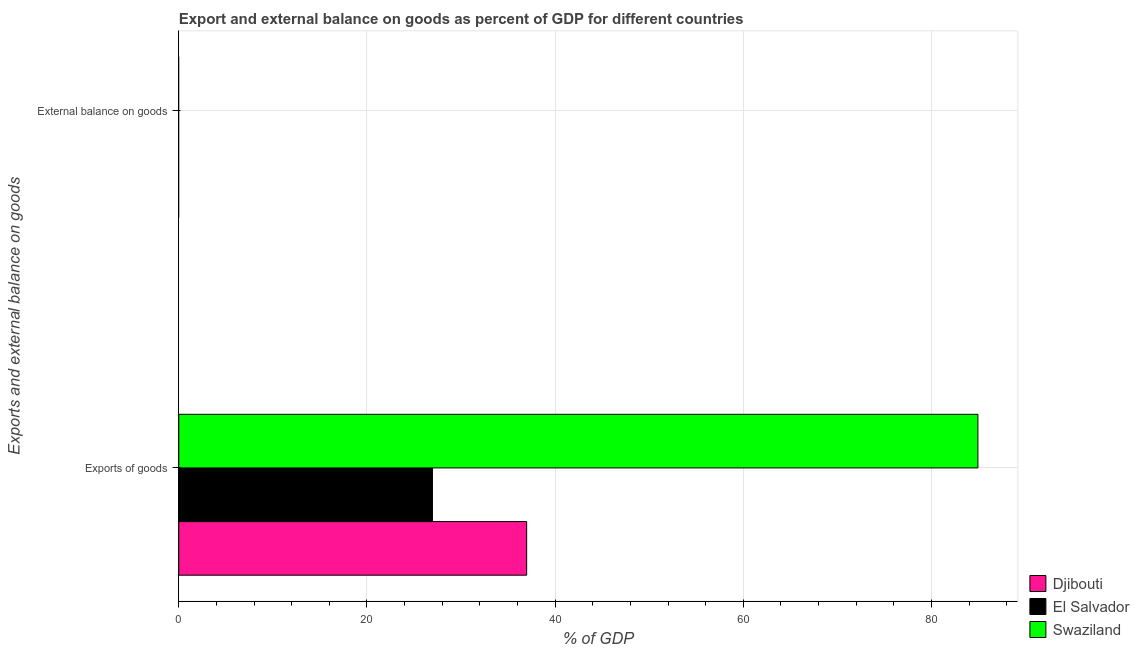Are the number of bars per tick equal to the number of legend labels?
Your answer should be very brief. No. Are the number of bars on each tick of the Y-axis equal?
Offer a very short reply. No. How many bars are there on the 1st tick from the bottom?
Offer a very short reply. 3. What is the label of the 1st group of bars from the top?
Make the answer very short. External balance on goods. What is the export of goods as percentage of gdp in Djibouti?
Give a very brief answer. 36.97. Across all countries, what is the maximum export of goods as percentage of gdp?
Your answer should be very brief. 84.93. In which country was the export of goods as percentage of gdp maximum?
Your answer should be compact. Swaziland. What is the total external balance on goods as percentage of gdp in the graph?
Give a very brief answer. 0. What is the difference between the export of goods as percentage of gdp in Djibouti and that in El Salvador?
Offer a very short reply. 10.01. What is the difference between the external balance on goods as percentage of gdp in Djibouti and the export of goods as percentage of gdp in Swaziland?
Your answer should be very brief. -84.93. What is the average export of goods as percentage of gdp per country?
Provide a succinct answer. 49.62. What is the ratio of the export of goods as percentage of gdp in El Salvador to that in Djibouti?
Provide a succinct answer. 0.73. Is the export of goods as percentage of gdp in Swaziland less than that in Djibouti?
Offer a terse response. No. How many countries are there in the graph?
Give a very brief answer. 3. What is the difference between two consecutive major ticks on the X-axis?
Provide a succinct answer. 20. Are the values on the major ticks of X-axis written in scientific E-notation?
Provide a succinct answer. No. Does the graph contain grids?
Provide a short and direct response. Yes. How are the legend labels stacked?
Provide a succinct answer. Vertical. What is the title of the graph?
Offer a very short reply. Export and external balance on goods as percent of GDP for different countries. Does "Palau" appear as one of the legend labels in the graph?
Offer a terse response. No. What is the label or title of the X-axis?
Your answer should be compact. % of GDP. What is the label or title of the Y-axis?
Provide a succinct answer. Exports and external balance on goods. What is the % of GDP in Djibouti in Exports of goods?
Keep it short and to the point. 36.97. What is the % of GDP in El Salvador in Exports of goods?
Keep it short and to the point. 26.96. What is the % of GDP of Swaziland in Exports of goods?
Provide a succinct answer. 84.93. What is the % of GDP in El Salvador in External balance on goods?
Your answer should be very brief. 0. What is the % of GDP of Swaziland in External balance on goods?
Offer a very short reply. 0. Across all Exports and external balance on goods, what is the maximum % of GDP in Djibouti?
Ensure brevity in your answer.  36.97. Across all Exports and external balance on goods, what is the maximum % of GDP in El Salvador?
Make the answer very short. 26.96. Across all Exports and external balance on goods, what is the maximum % of GDP of Swaziland?
Give a very brief answer. 84.93. What is the total % of GDP in Djibouti in the graph?
Your answer should be compact. 36.97. What is the total % of GDP of El Salvador in the graph?
Your response must be concise. 26.96. What is the total % of GDP in Swaziland in the graph?
Your answer should be compact. 84.93. What is the average % of GDP in Djibouti per Exports and external balance on goods?
Give a very brief answer. 18.49. What is the average % of GDP in El Salvador per Exports and external balance on goods?
Provide a succinct answer. 13.48. What is the average % of GDP in Swaziland per Exports and external balance on goods?
Offer a very short reply. 42.46. What is the difference between the % of GDP in Djibouti and % of GDP in El Salvador in Exports of goods?
Provide a succinct answer. 10.01. What is the difference between the % of GDP of Djibouti and % of GDP of Swaziland in Exports of goods?
Give a very brief answer. -47.96. What is the difference between the % of GDP of El Salvador and % of GDP of Swaziland in Exports of goods?
Provide a succinct answer. -57.97. What is the difference between the highest and the lowest % of GDP of Djibouti?
Provide a succinct answer. 36.97. What is the difference between the highest and the lowest % of GDP of El Salvador?
Keep it short and to the point. 26.96. What is the difference between the highest and the lowest % of GDP of Swaziland?
Your response must be concise. 84.93. 